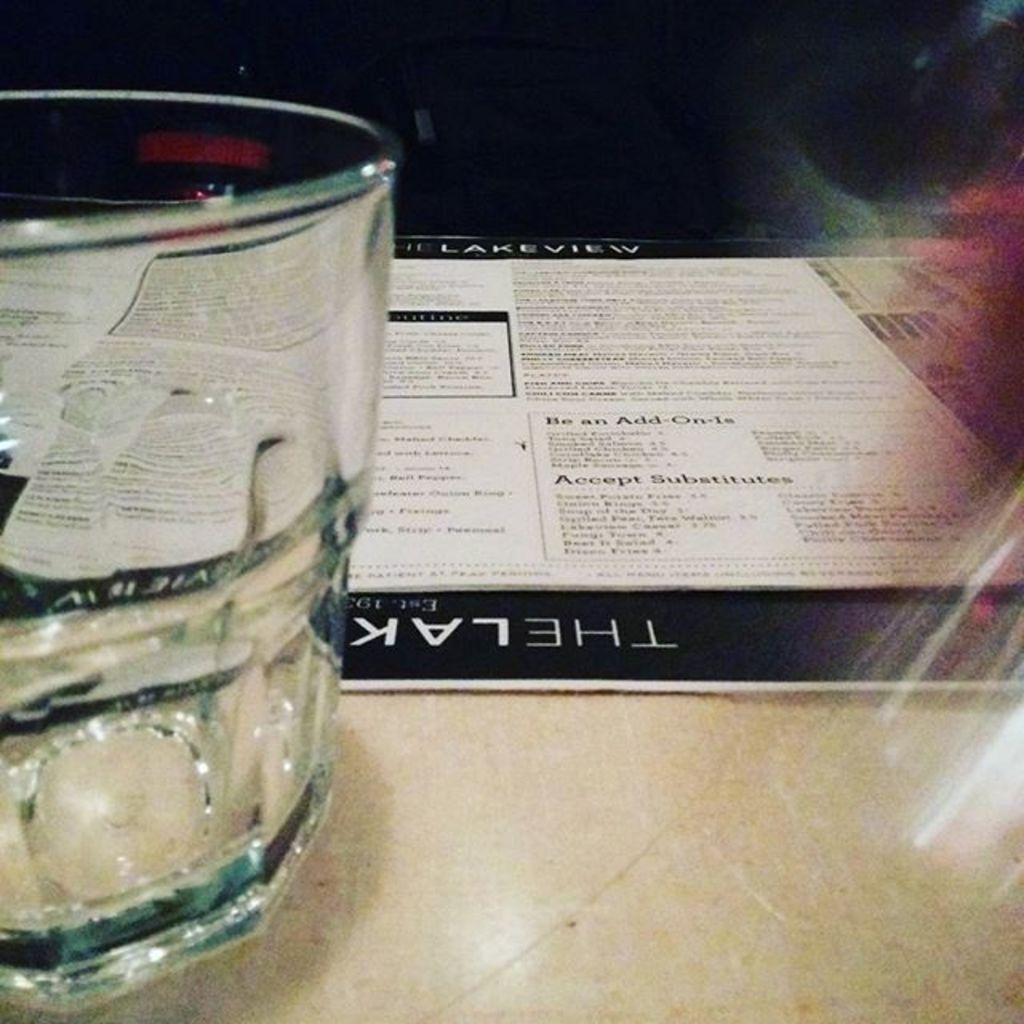<image>
Give a short and clear explanation of the subsequent image. An empty tumbler in front of a menu for the Lakeview that is laying on a table. 